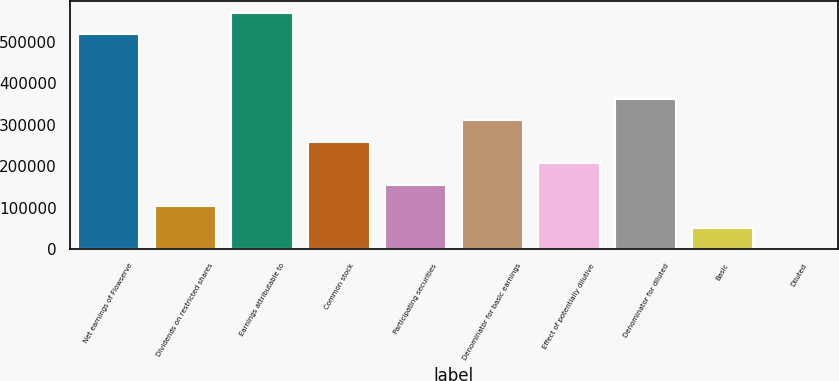Convert chart to OTSL. <chart><loc_0><loc_0><loc_500><loc_500><bar_chart><fcel>Net earnings of Flowserve<fcel>Dividends on restricted shares<fcel>Earnings attributable to<fcel>Common stock<fcel>Participating securities<fcel>Denominator for basic earnings<fcel>Effect of potentially dilutive<fcel>Denominator for diluted<fcel>Basic<fcel>Diluted<nl><fcel>518824<fcel>103770<fcel>570707<fcel>259420<fcel>155653<fcel>311303<fcel>207537<fcel>363186<fcel>51887<fcel>3.76<nl></chart> 